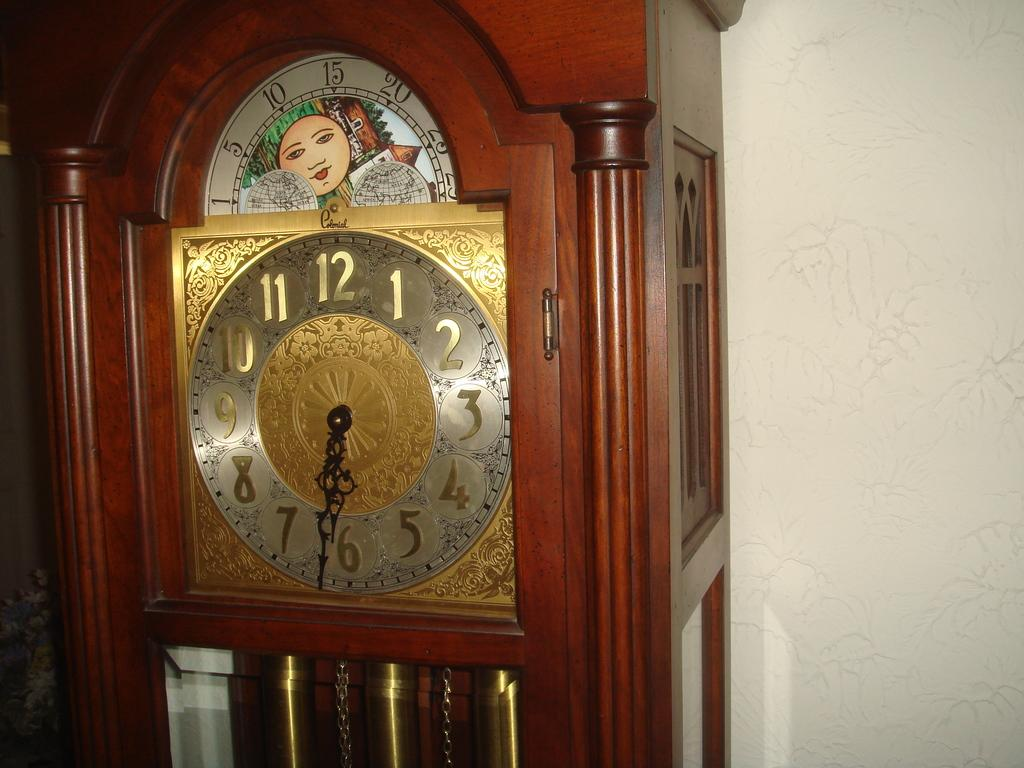<image>
Write a terse but informative summary of the picture. Old clock that has the hands in between the numbers 6 and 7. 